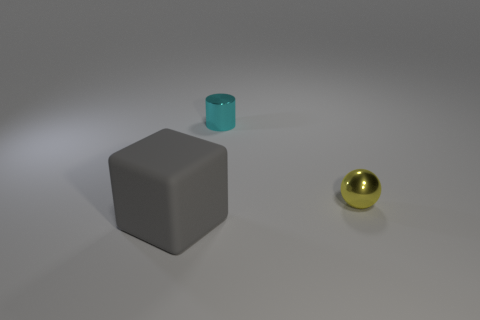How many green objects are metal balls or tiny metallic cylinders? In the image, there is one green object which appears as a small cylinder with a metallic finish, indicating that there is precisely one green metallic object. 